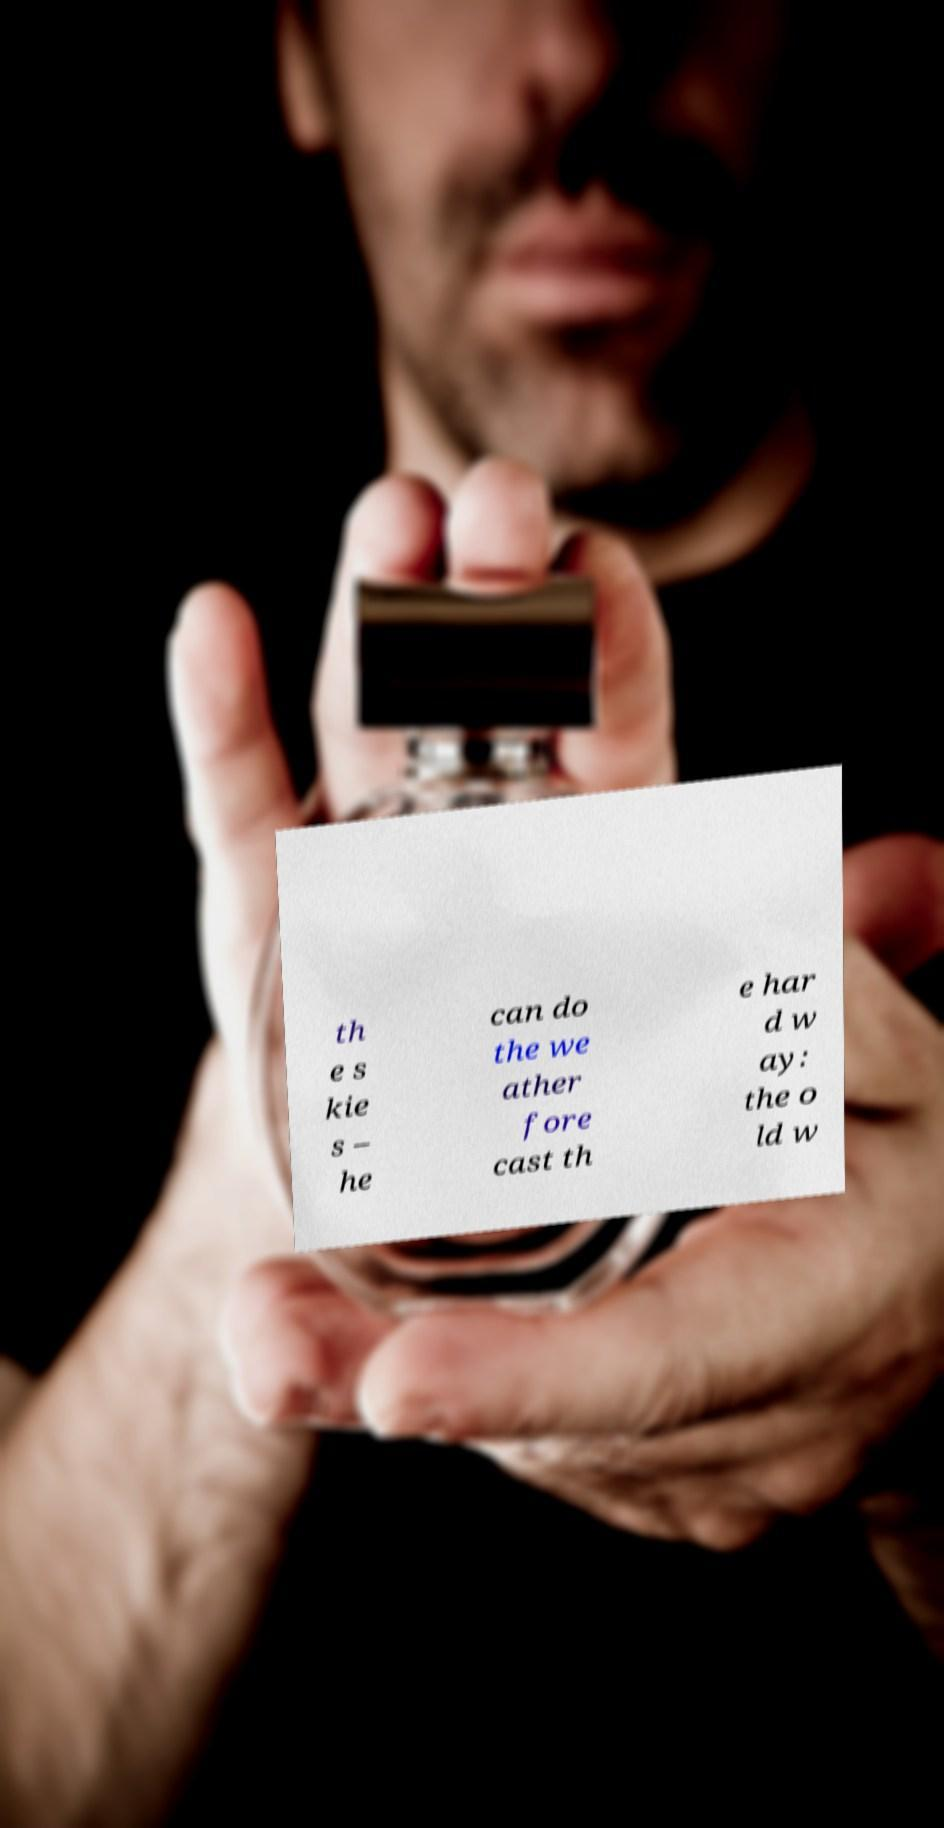Please read and relay the text visible in this image. What does it say? th e s kie s – he can do the we ather fore cast th e har d w ay: the o ld w 